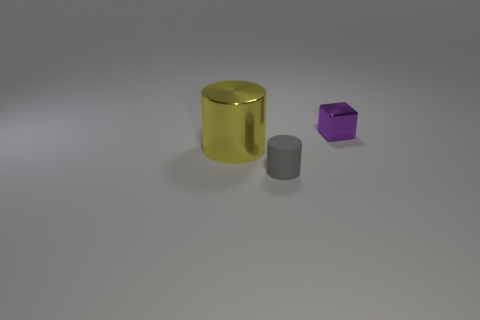What is the lighting situation like where these objects are placed? The objects appear to be under a diffused lighting source that minimizes shadows and evenly illuminates the scene, which suggests an indoor environment possibly with studio lighting. 